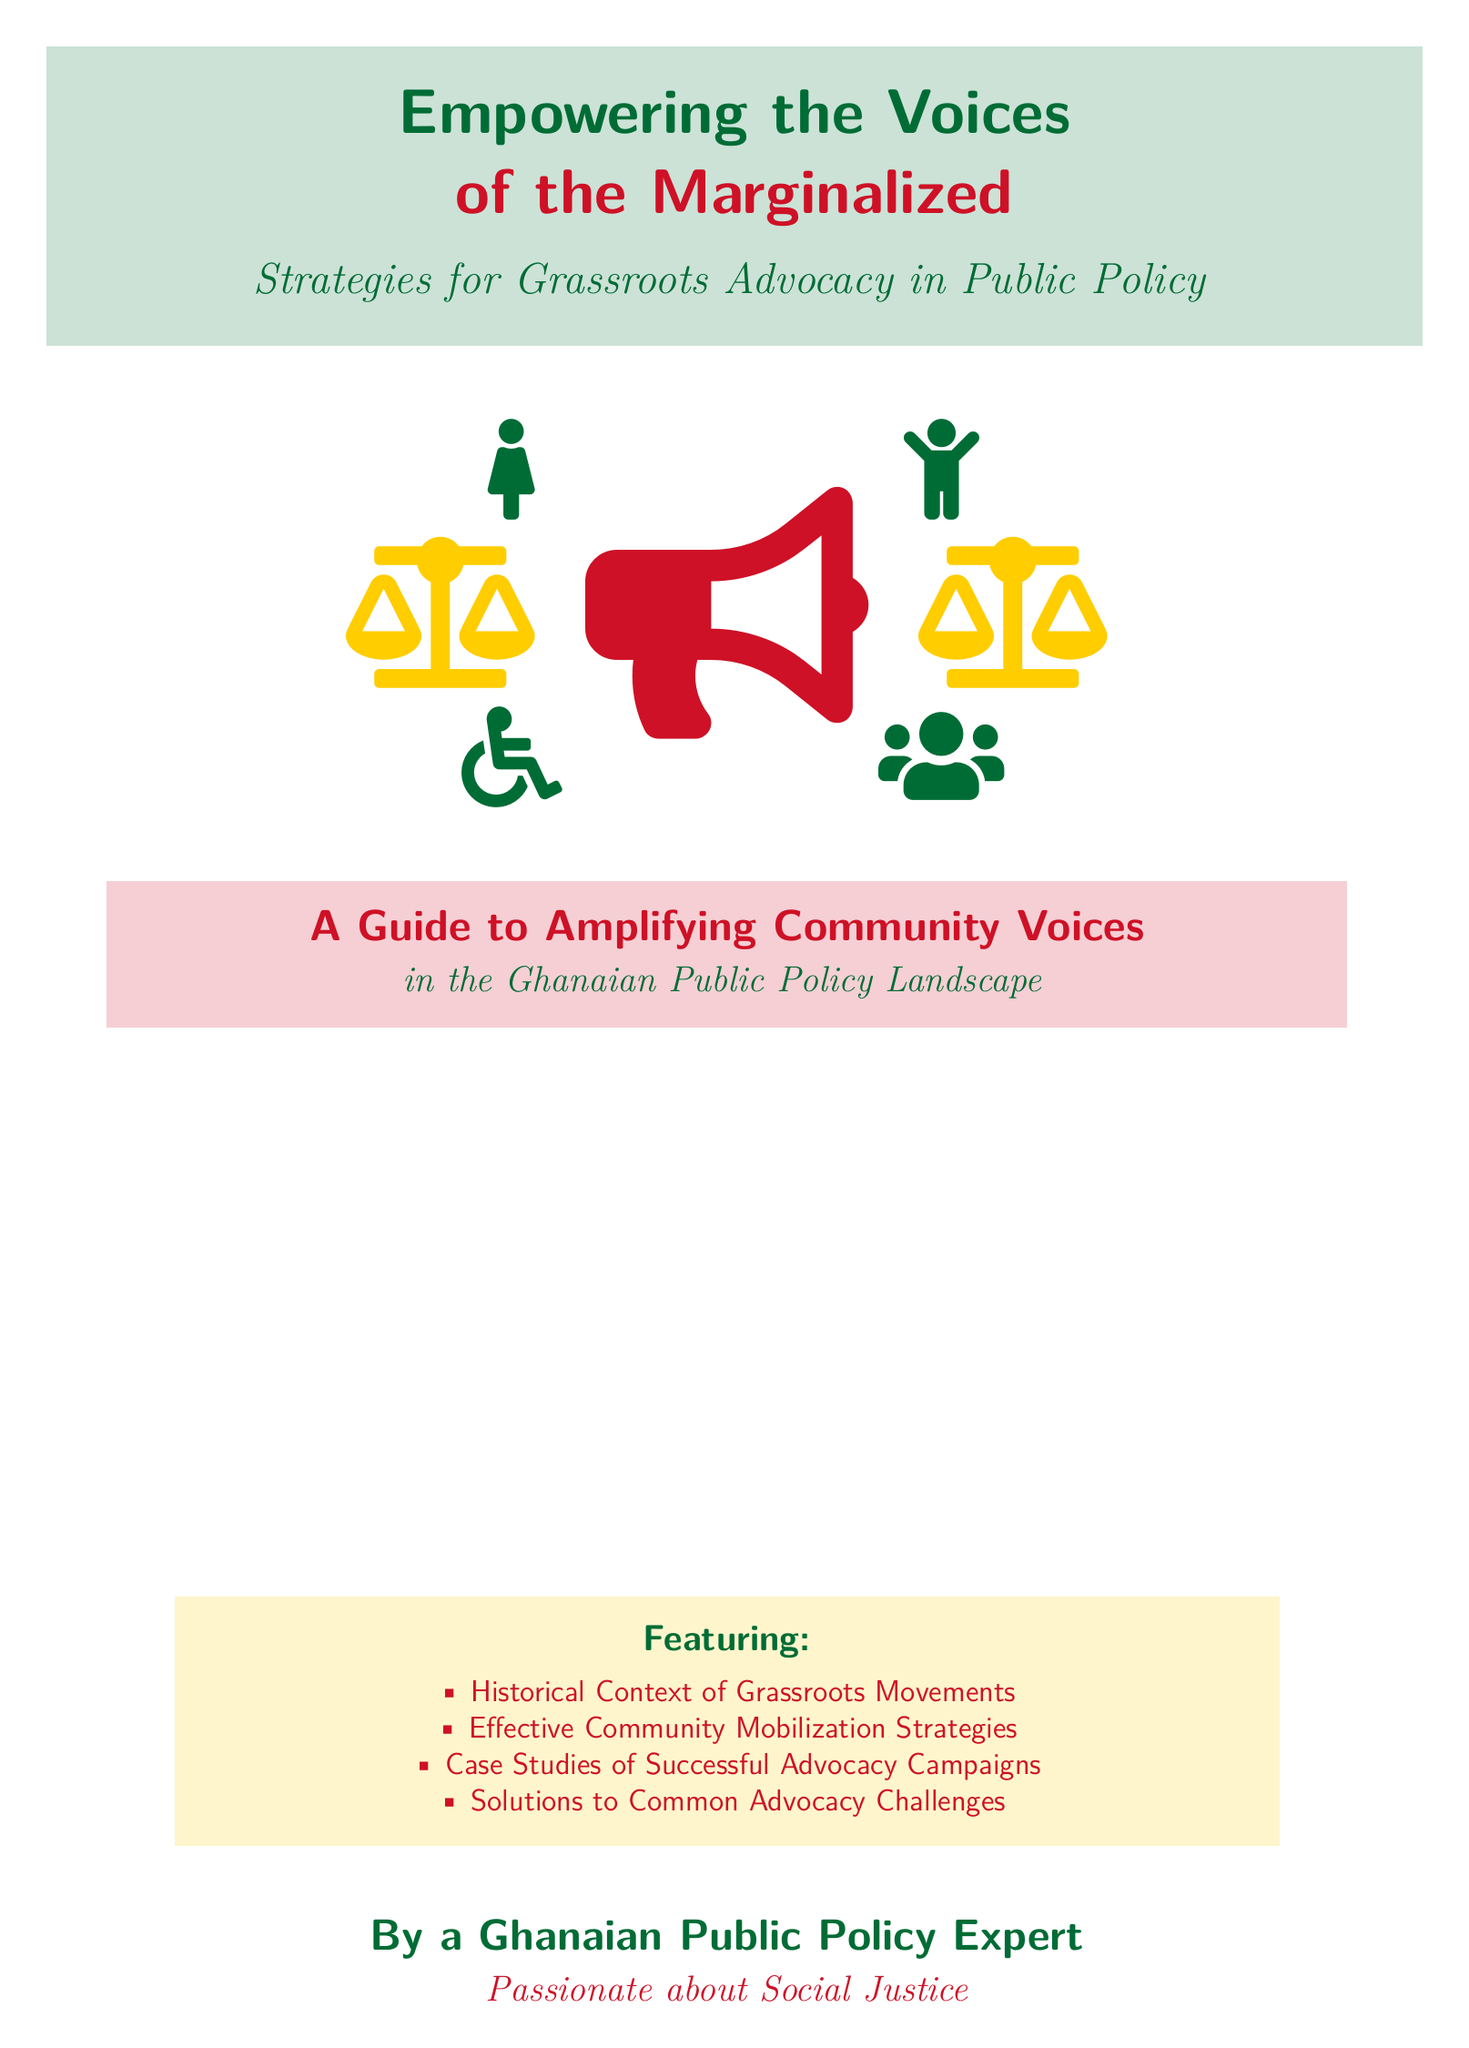What is the main title of the book? The main title is prominently featured at the top of the cover.
Answer: Empowering the Voices Who is the author of the book? The author's description is provided at the bottom of the cover.
Answer: A Ghanaian Public Policy Expert What color is the megaphone depicted on the cover? The color of the megaphone is specified in the document's visual description.
Answer: Red What is one of the features highlighted in the book? The features are listed in a section of the cover, providing insight into the book's content.
Answer: Historical Context of Grassroots Movements How many icons representing social groups are surrounding the megaphone? The document mentions specific icons that symbolize various social groups around the megaphone.
Answer: Four What background setting is depicted in the cover image? The setting mentioned in the description reflects the overall theme of the book cover.
Answer: Village meeting What color represents justice scales on the cover? The color of the justice scales is noted in the visual description provided in the document.
Answer: Yellow What type of advocacy does the book focus on? The book's subtitle indicates the area of advocacy it aims to address.
Answer: Grassroots Advocacy 